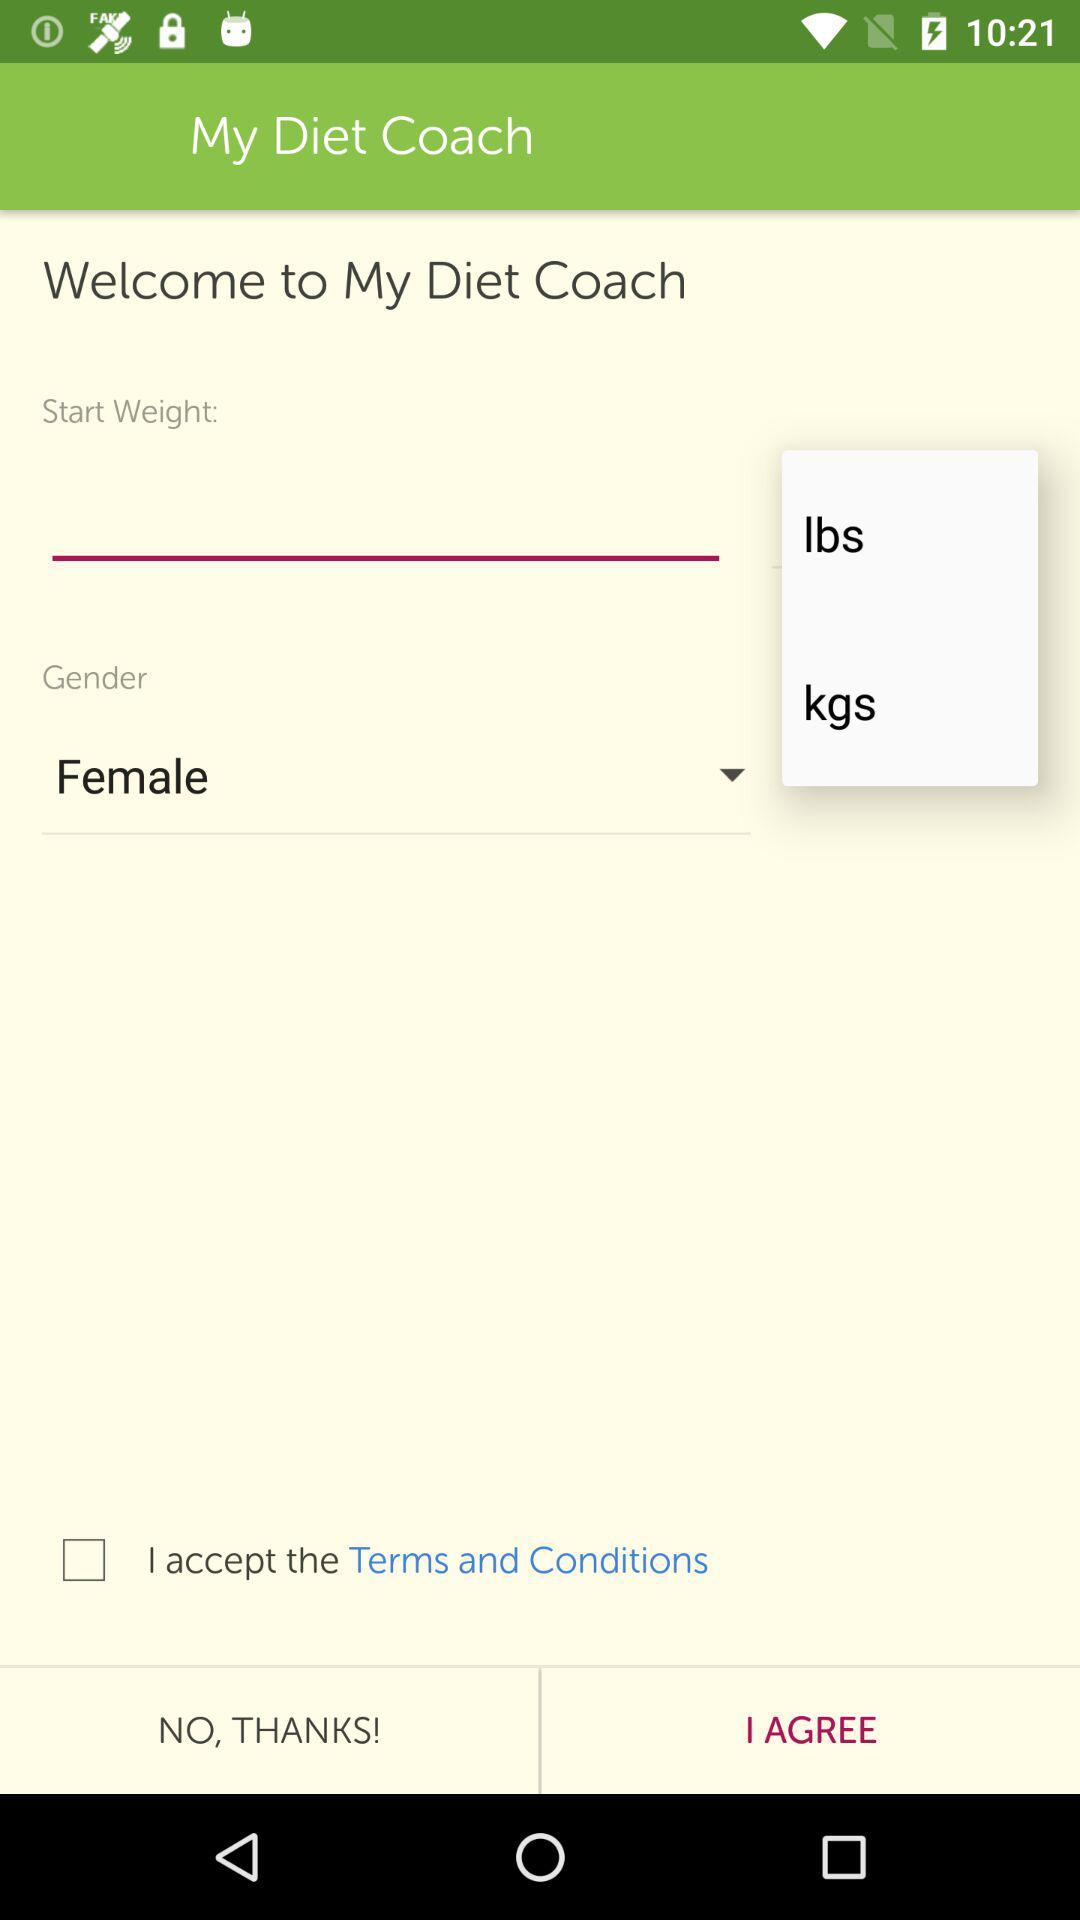What is the application name? The application name is "My Diet Coach". 